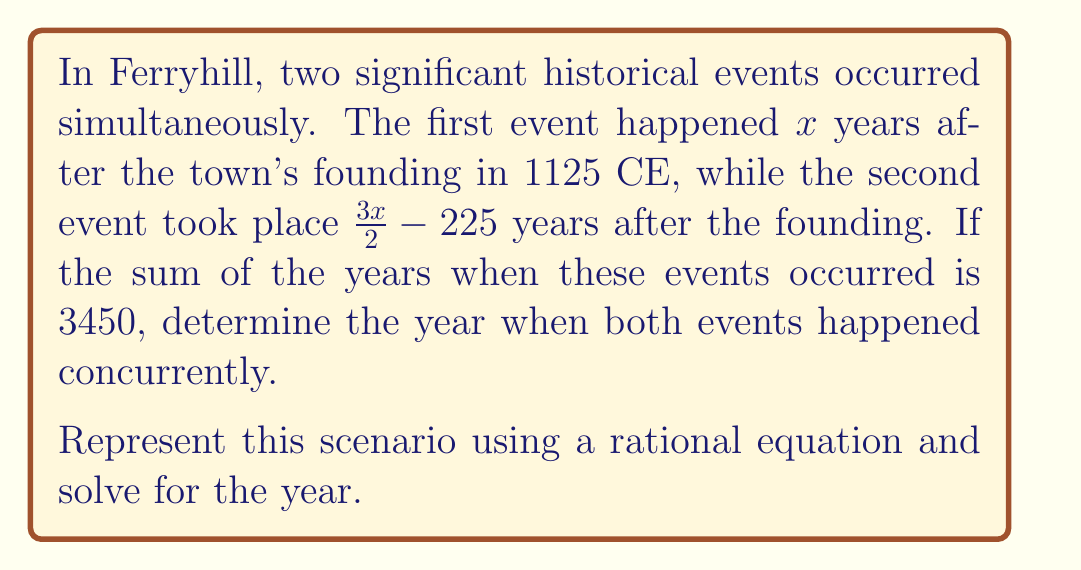Can you solve this math problem? Let's solve this problem step by step:

1) Let $y$ be the year when both events occurred simultaneously.

2) We can express $y$ in two ways:
   - For the first event: $y = 1125 + x$
   - For the second event: $y = 1125 + (\frac{3x}{2} - 225)$

3) We're told that the sum of these years is 3450. Let's set up our equation:
   $$(1125 + x) + (1125 + \frac{3x}{2} - 225) = 3450$$

4) Simplify the left side of the equation:
   $$2250 + x + \frac{3x}{2} - 225 = 3450$$
   $$2025 + x + \frac{3x}{2} = 3450$$

5) Combine like terms:
   $$2025 + \frac{5x}{2} = 3450$$

6) Subtract 2025 from both sides:
   $$\frac{5x}{2} = 1425$$

7) Multiply both sides by 2:
   $$5x = 2850$$

8) Divide both sides by 5:
   $$x = 570$$

9) Remember, $x$ represents the number of years after 1125. To find the actual year, add 1125:
   $$y = 1125 + 570 = 1695$$

Therefore, both events occurred simultaneously in the year 1695.
Answer: 1695 CE 